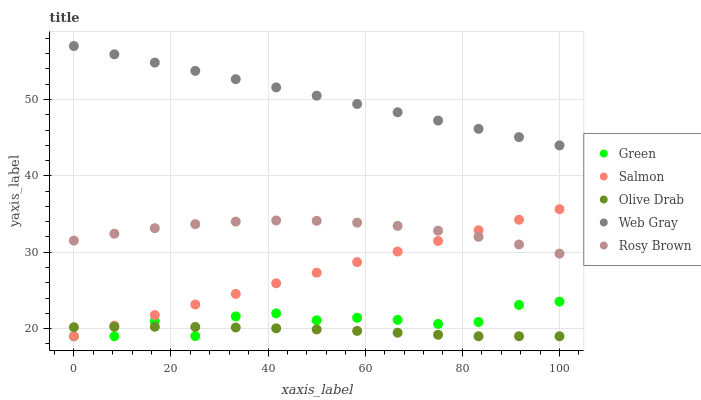Does Olive Drab have the minimum area under the curve?
Answer yes or no. Yes. Does Web Gray have the maximum area under the curve?
Answer yes or no. Yes. Does Rosy Brown have the minimum area under the curve?
Answer yes or no. No. Does Rosy Brown have the maximum area under the curve?
Answer yes or no. No. Is Salmon the smoothest?
Answer yes or no. Yes. Is Green the roughest?
Answer yes or no. Yes. Is Rosy Brown the smoothest?
Answer yes or no. No. Is Rosy Brown the roughest?
Answer yes or no. No. Does Salmon have the lowest value?
Answer yes or no. Yes. Does Rosy Brown have the lowest value?
Answer yes or no. No. Does Web Gray have the highest value?
Answer yes or no. Yes. Does Rosy Brown have the highest value?
Answer yes or no. No. Is Salmon less than Web Gray?
Answer yes or no. Yes. Is Rosy Brown greater than Green?
Answer yes or no. Yes. Does Olive Drab intersect Green?
Answer yes or no. Yes. Is Olive Drab less than Green?
Answer yes or no. No. Is Olive Drab greater than Green?
Answer yes or no. No. Does Salmon intersect Web Gray?
Answer yes or no. No. 